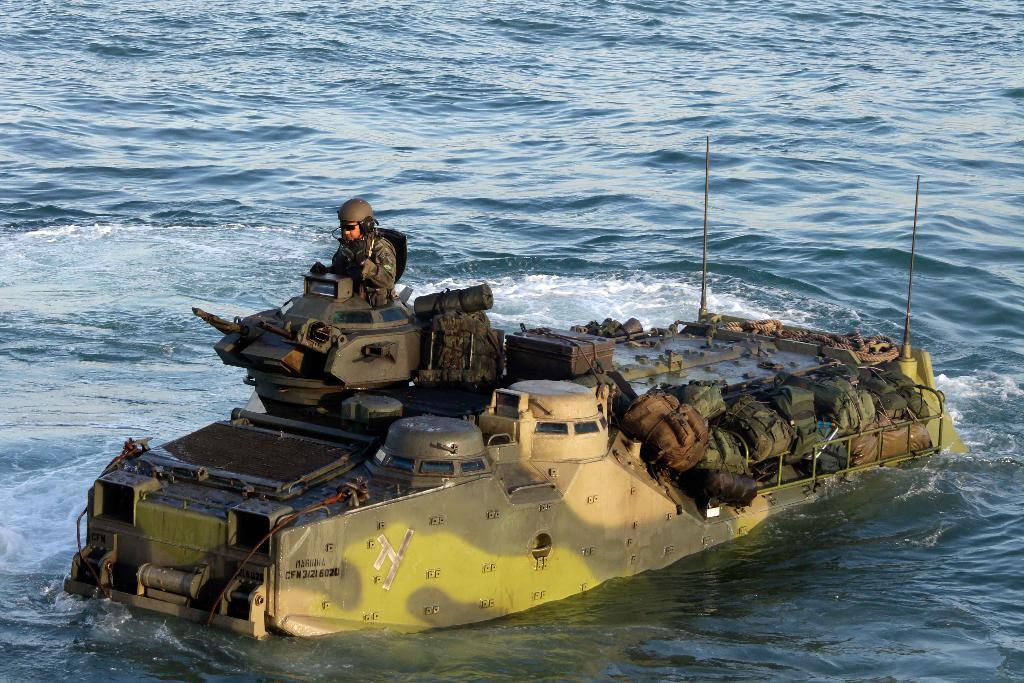What is the main subject of the image? The main subject of the image is a submarine. Where is the submarine located in the image? The submarine is in the middle of the image. What else can be seen in the image besides the submarine? There is a man standing in front of the submarine. What is the setting of the image? The submarine and the man are in the ocean. Can you tell me how the lawyer is interacting with the submarine in the image? There is no lawyer present in the image; it features a submarine and a man in the ocean. 